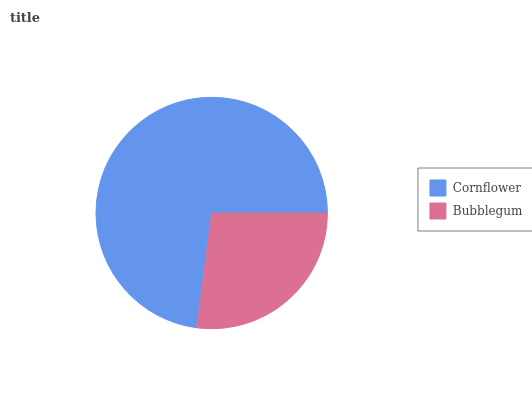Is Bubblegum the minimum?
Answer yes or no. Yes. Is Cornflower the maximum?
Answer yes or no. Yes. Is Bubblegum the maximum?
Answer yes or no. No. Is Cornflower greater than Bubblegum?
Answer yes or no. Yes. Is Bubblegum less than Cornflower?
Answer yes or no. Yes. Is Bubblegum greater than Cornflower?
Answer yes or no. No. Is Cornflower less than Bubblegum?
Answer yes or no. No. Is Cornflower the high median?
Answer yes or no. Yes. Is Bubblegum the low median?
Answer yes or no. Yes. Is Bubblegum the high median?
Answer yes or no. No. Is Cornflower the low median?
Answer yes or no. No. 